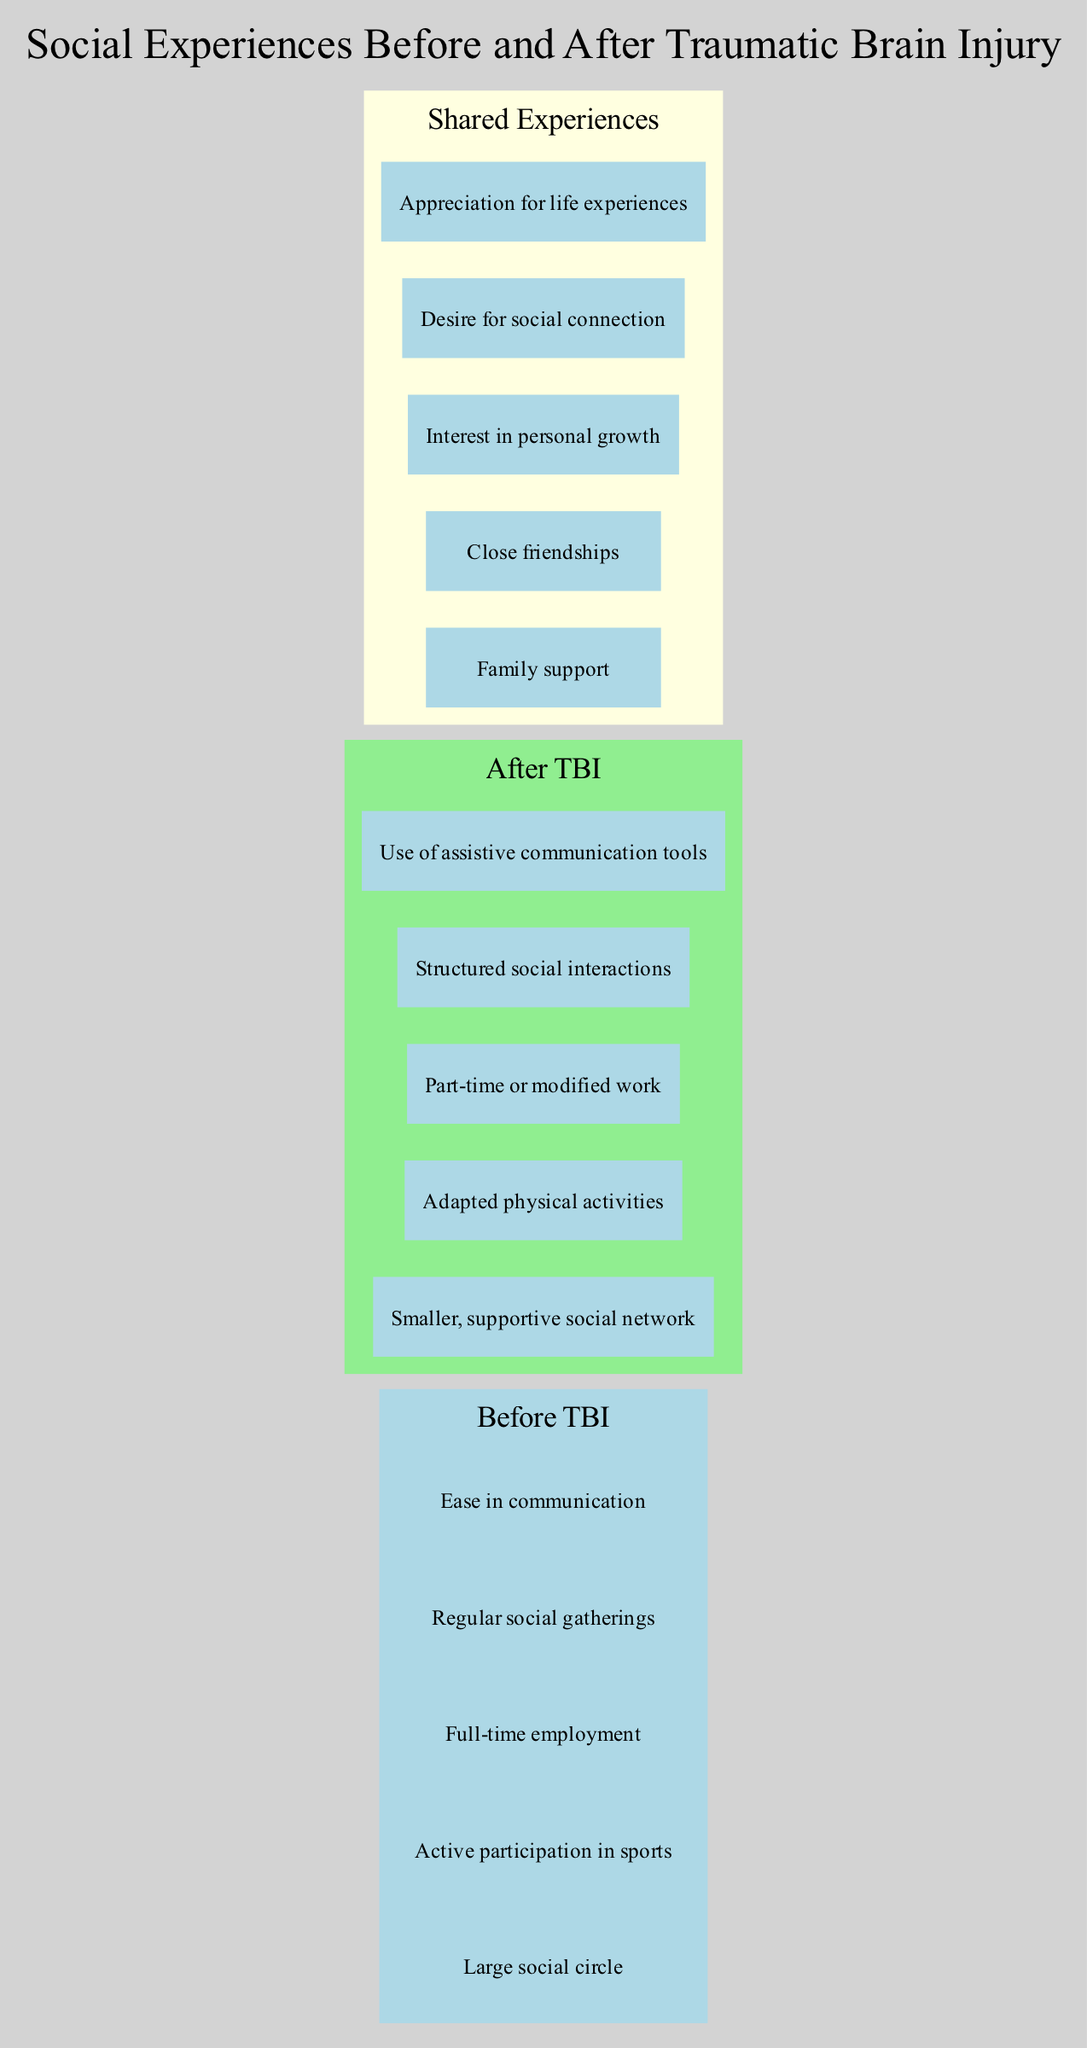What elements are included in the "Before TBI" set? The diagram lists five elements that represent social experiences before the traumatic brain injury, which are: Large social circle, Active participation in sports, Full-time employment, Regular social gatherings, and Ease in communication.
Answer: Large social circle, Active participation in sports, Full-time employment, Regular social gatherings, Ease in communication How many elements are in the "After TBI" set? The "After TBI" set has five distinct elements. This can be determined by counting the items listed in that section of the diagram.
Answer: 5 What is one shared experience between "Before TBI" and "After TBI"? The diagram includes several shared experiences in the intersection area, demonstrating what remains constant before and after the injury. One example listed is "Family support."
Answer: Family support Which category shows the element "Adapted physical activities"? The element "Adapted physical activities" is part of the "After TBI" set, which signifies the changes experienced following the traumatic brain injury. This can be deduced by locating the element within the respective area set for "After TBI."
Answer: After TBI Is "Ease in communication" found in the shared experiences section? The element "Ease in communication" is not included in the intersection area of shared experiences but is featured solely in the "Before TBI" set. This is confirmed by checking the items listed in the intersection section of the diagram.
Answer: No Why might the social network size change after TBI? The change in social network size after TBI could be influenced by several factors illustrated in the diagram. Typically, social experiences may be impacted by the increased need for support and possible limitations resulting from the injury, which leads to a smaller, more supportive social network compared to the larger social circle pre-injury.
Answer: Increased need for support What effect does TBI have on employment as shown in the diagram? The diagram indicates that individuals typically transition from "Full-time employment" before the injury to "Part-time or modified work" afterward, reflecting the adjustments necessary due to the injury's impact on their capabilities. This shows a significant change in employment status as illustrated in the respective sections.
Answer: Part-time or modified work How many elements are listed in the shared experiences? In the intersection area labeled "Shared Experiences," there are five elements listed, representing the aspects that remain unchanged before and after the traumatic brain injury. This can be confirmed by counting the items under that section in the diagram.
Answer: 5 What does the element "Desire for social connection" signify in this diagram? The element "Desire for social connection" represents an emotional aspect that persists even after the traumatic brain injury, indicating that the individual still values social interactions despite the changes experienced. This element is part of the shared experiences that denote continuity in social wants.
Answer: Continuity in social wants What does the color scheme of the diagram signify about the sets? The color scheme differentiates the sets: "Before TBI" is shown in light blue, highlighting a past experience, while "After TBI" is displayed in light green, indicating a new reality post-injury. The color coding aids in quickly identifying the sections related to the timeline of events regarding the traumatic brain injury.
Answer: Differentiates past and present experiences 